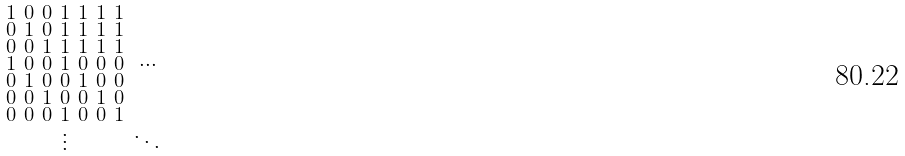<formula> <loc_0><loc_0><loc_500><loc_500>\begin{smallmatrix} 1 & 0 & 0 & 1 & 1 & 1 & 1 & \\ 0 & 1 & 0 & 1 & 1 & 1 & 1 & \\ 0 & 0 & 1 & 1 & 1 & 1 & 1 & \\ 1 & 0 & 0 & 1 & 0 & 0 & 0 & \cdots \\ 0 & 1 & 0 & 0 & 1 & 0 & 0 & \\ 0 & 0 & 1 & 0 & 0 & 1 & 0 & \\ 0 & 0 & 0 & 1 & 0 & 0 & 1 & \\ & & & \vdots & & & & \ddots \\ \end{smallmatrix}</formula> 